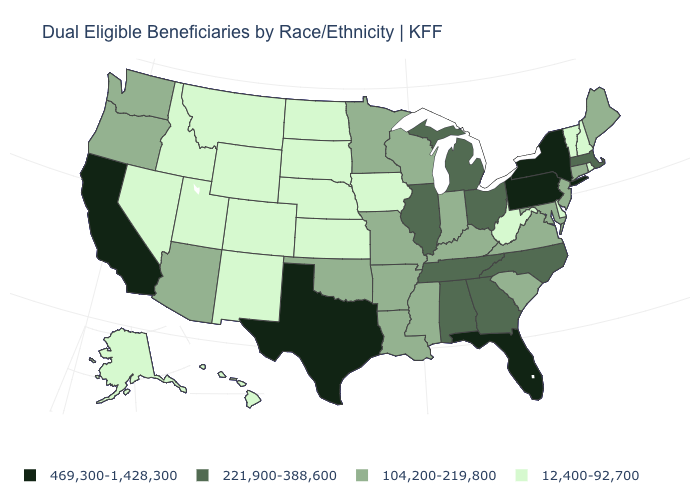What is the value of Colorado?
Give a very brief answer. 12,400-92,700. What is the value of Massachusetts?
Answer briefly. 221,900-388,600. Name the states that have a value in the range 469,300-1,428,300?
Be succinct. California, Florida, New York, Pennsylvania, Texas. What is the value of Alaska?
Give a very brief answer. 12,400-92,700. How many symbols are there in the legend?
Short answer required. 4. Among the states that border Colorado , which have the lowest value?
Quick response, please. Kansas, Nebraska, New Mexico, Utah, Wyoming. Name the states that have a value in the range 221,900-388,600?
Give a very brief answer. Alabama, Georgia, Illinois, Massachusetts, Michigan, North Carolina, Ohio, Tennessee. Which states have the lowest value in the MidWest?
Be succinct. Iowa, Kansas, Nebraska, North Dakota, South Dakota. Which states have the lowest value in the South?
Write a very short answer. Delaware, West Virginia. What is the value of New Mexico?
Short answer required. 12,400-92,700. What is the value of South Carolina?
Be succinct. 104,200-219,800. What is the lowest value in the USA?
Be succinct. 12,400-92,700. What is the value of Utah?
Write a very short answer. 12,400-92,700. Does Pennsylvania have the highest value in the USA?
Answer briefly. Yes. Among the states that border North Carolina , does South Carolina have the lowest value?
Short answer required. Yes. 